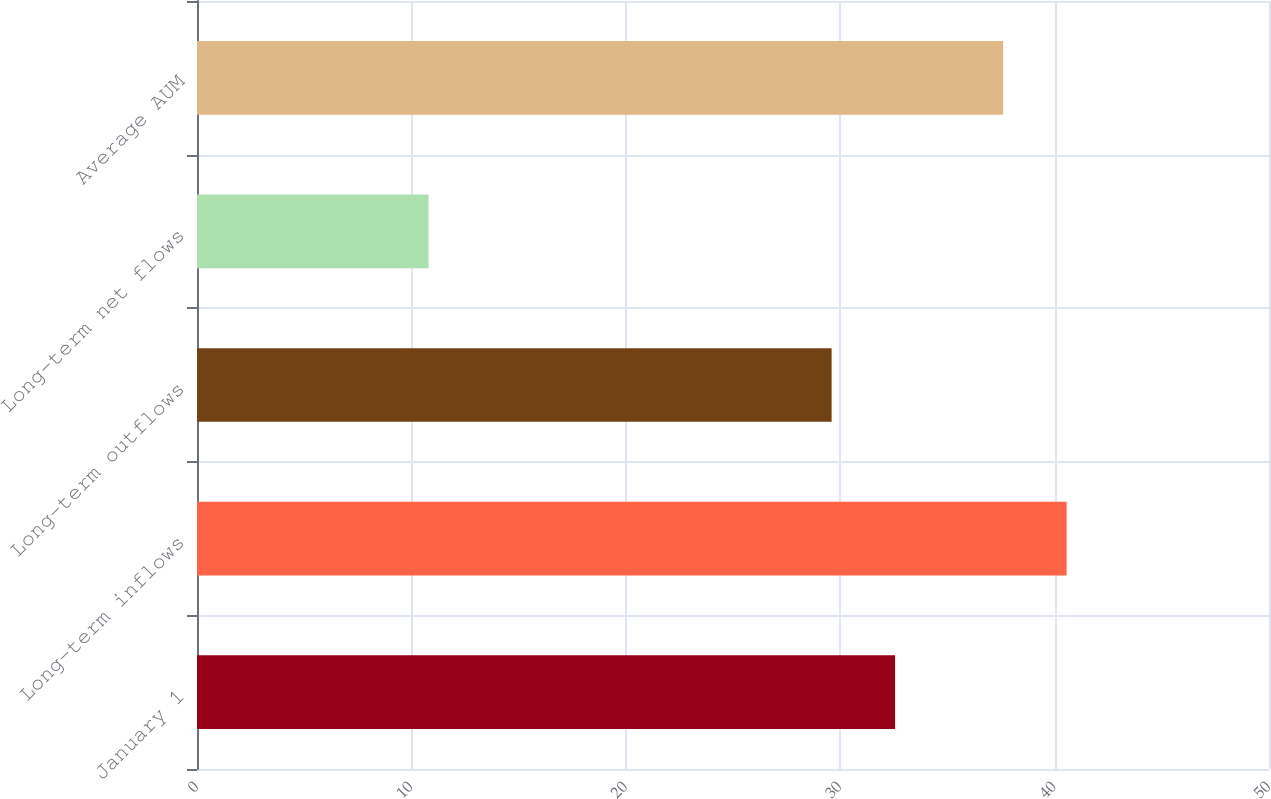Convert chart to OTSL. <chart><loc_0><loc_0><loc_500><loc_500><bar_chart><fcel>January 1<fcel>Long-term inflows<fcel>Long-term outflows<fcel>Long-term net flows<fcel>Average AUM<nl><fcel>32.56<fcel>40.56<fcel>29.6<fcel>10.8<fcel>37.6<nl></chart> 